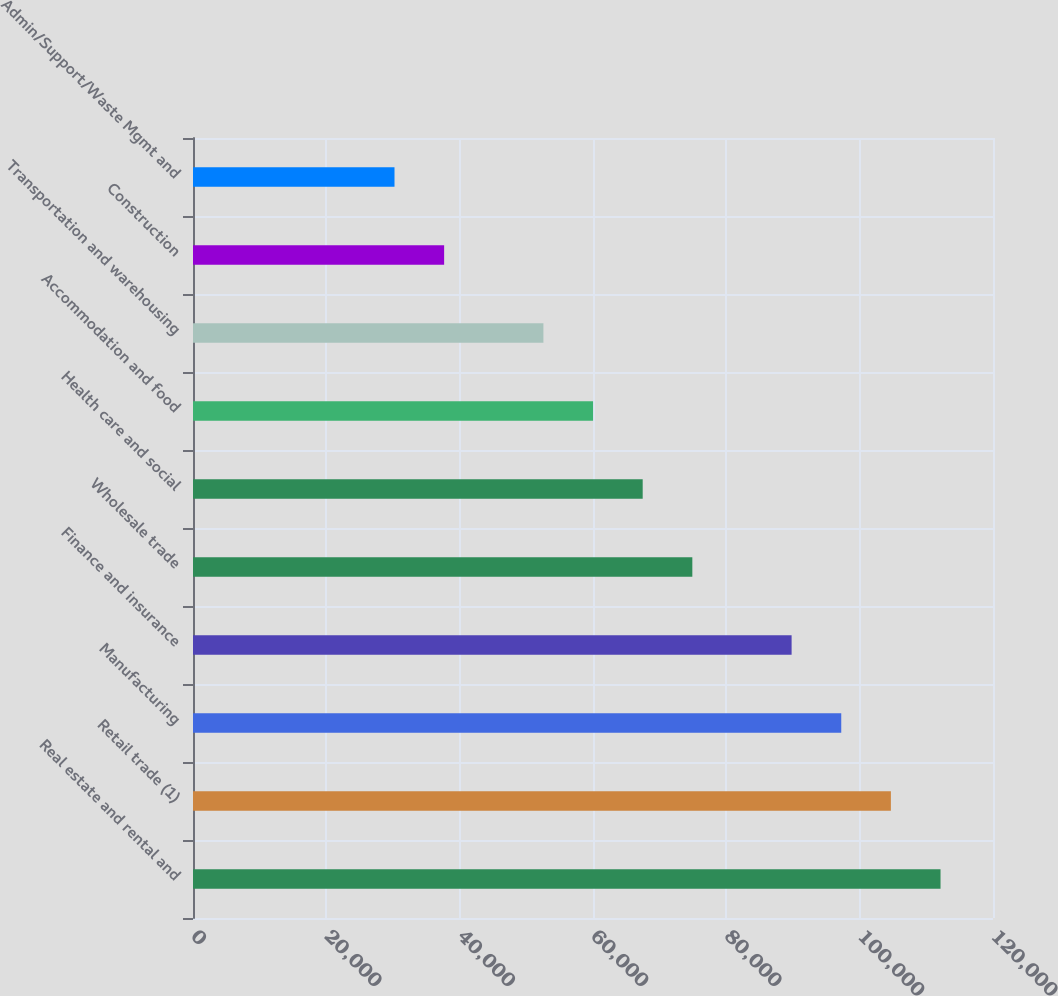Convert chart. <chart><loc_0><loc_0><loc_500><loc_500><bar_chart><fcel>Real estate and rental and<fcel>Retail trade (1)<fcel>Manufacturing<fcel>Finance and insurance<fcel>Wholesale trade<fcel>Health care and social<fcel>Accommodation and food<fcel>Transportation and warehousing<fcel>Construction<fcel>Admin/Support/Waste Mgmt and<nl><fcel>112130<fcel>104684<fcel>97237.7<fcel>89791.8<fcel>74900<fcel>67454.1<fcel>60008.2<fcel>52562.3<fcel>37670.5<fcel>30224.6<nl></chart> 